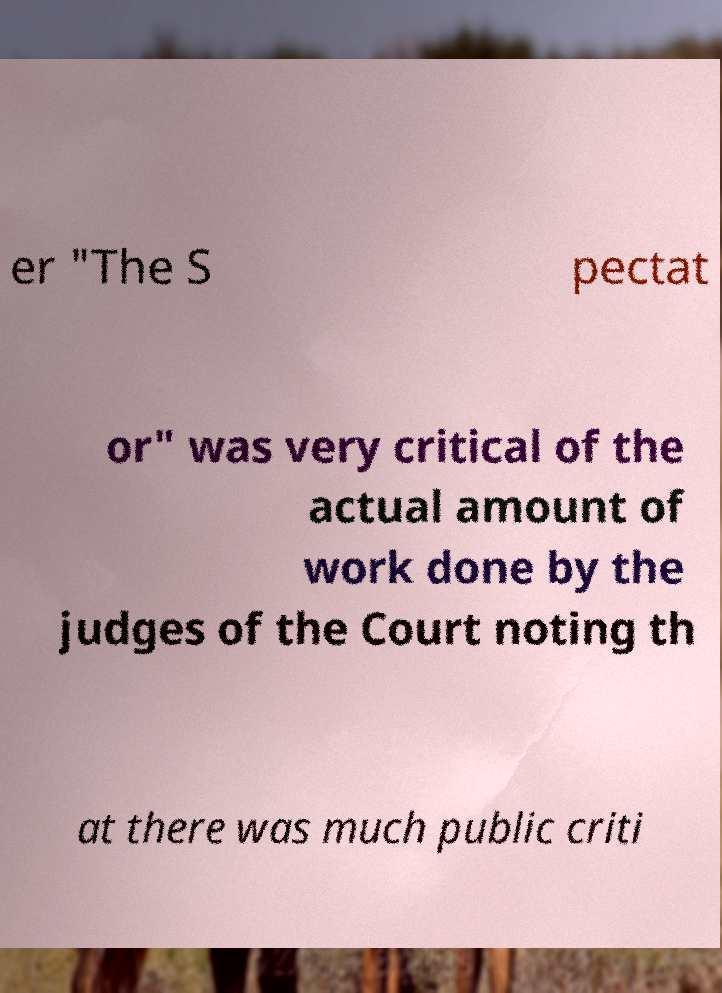There's text embedded in this image that I need extracted. Can you transcribe it verbatim? er "The S pectat or" was very critical of the actual amount of work done by the judges of the Court noting th at there was much public criti 